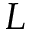<formula> <loc_0><loc_0><loc_500><loc_500>L</formula> 